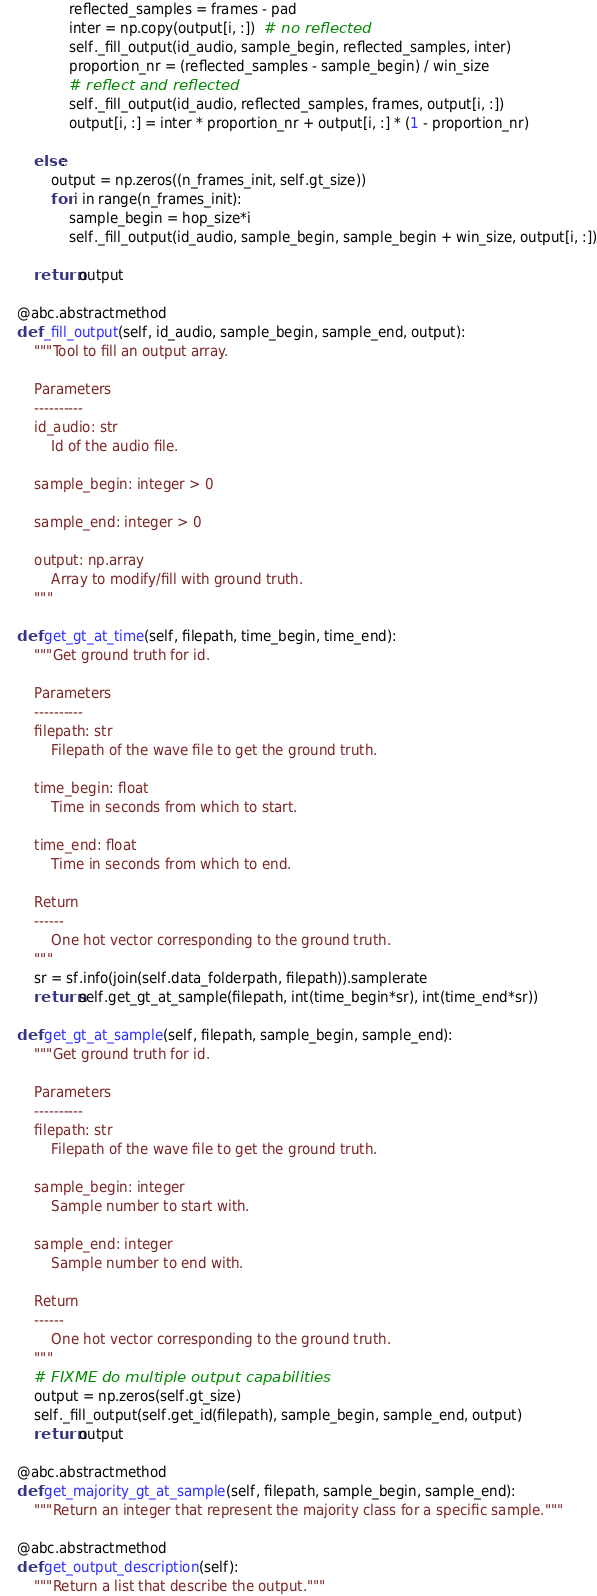Convert code to text. <code><loc_0><loc_0><loc_500><loc_500><_Python_>                reflected_samples = frames - pad
                inter = np.copy(output[i, :])  # no reflected
                self._fill_output(id_audio, sample_begin, reflected_samples, inter)
                proportion_nr = (reflected_samples - sample_begin) / win_size
                # reflect and reflected
                self._fill_output(id_audio, reflected_samples, frames, output[i, :])
                output[i, :] = inter * proportion_nr + output[i, :] * (1 - proportion_nr)

        else:
            output = np.zeros((n_frames_init, self.gt_size))
            for i in range(n_frames_init):
                sample_begin = hop_size*i
                self._fill_output(id_audio, sample_begin, sample_begin + win_size, output[i, :])

        return output

    @abc.abstractmethod
    def _fill_output(self, id_audio, sample_begin, sample_end, output):
        """Tool to fill an output array.

        Parameters
        ----------
        id_audio: str
            Id of the audio file.

        sample_begin: integer > 0

        sample_end: integer > 0

        output: np.array
            Array to modify/fill with ground truth.
        """

    def get_gt_at_time(self, filepath, time_begin, time_end):
        """Get ground truth for id.

        Parameters
        ----------
        filepath: str
            Filepath of the wave file to get the ground truth.

        time_begin: float
            Time in seconds from which to start.

        time_end: float
            Time in seconds from which to end.

        Return
        ------
            One hot vector corresponding to the ground truth.
        """
        sr = sf.info(join(self.data_folderpath, filepath)).samplerate
        return self.get_gt_at_sample(filepath, int(time_begin*sr), int(time_end*sr))

    def get_gt_at_sample(self, filepath, sample_begin, sample_end):
        """Get ground truth for id.

        Parameters
        ----------
        filepath: str
            Filepath of the wave file to get the ground truth.

        sample_begin: integer
            Sample number to start with.

        sample_end: integer
            Sample number to end with.

        Return
        ------
            One hot vector corresponding to the ground truth.
        """
        # FIXME do multiple output capabilities
        output = np.zeros(self.gt_size)
        self._fill_output(self.get_id(filepath), sample_begin, sample_end, output)
        return output

    @abc.abstractmethod
    def get_majority_gt_at_sample(self, filepath, sample_begin, sample_end):
        """Return an integer that represent the majority class for a specific sample."""

    @abc.abstractmethod
    def get_output_description(self):
        """Return a list that describe the output."""
</code> 